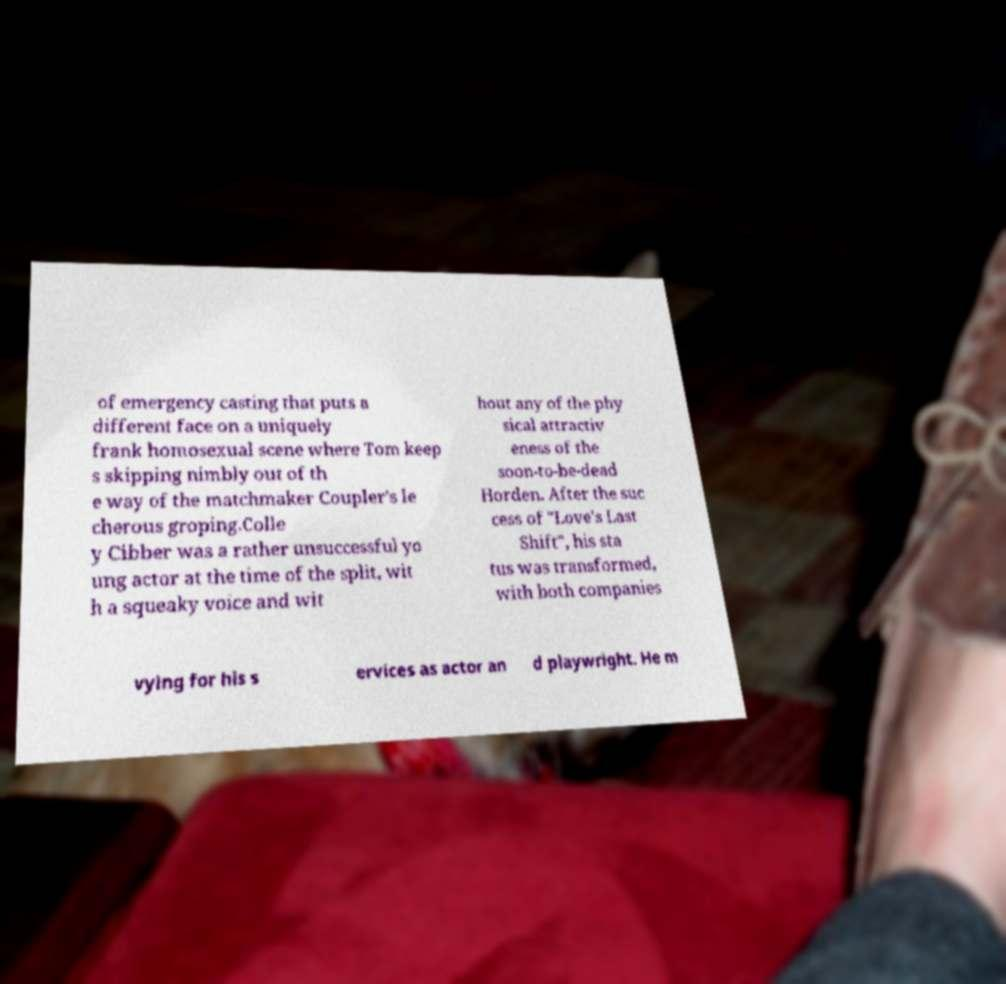I need the written content from this picture converted into text. Can you do that? of emergency casting that puts a different face on a uniquely frank homosexual scene where Tom keep s skipping nimbly out of th e way of the matchmaker Coupler's le cherous groping.Colle y Cibber was a rather unsuccessful yo ung actor at the time of the split, wit h a squeaky voice and wit hout any of the phy sical attractiv eness of the soon-to-be-dead Horden. After the suc cess of "Love's Last Shift", his sta tus was transformed, with both companies vying for his s ervices as actor an d playwright. He m 